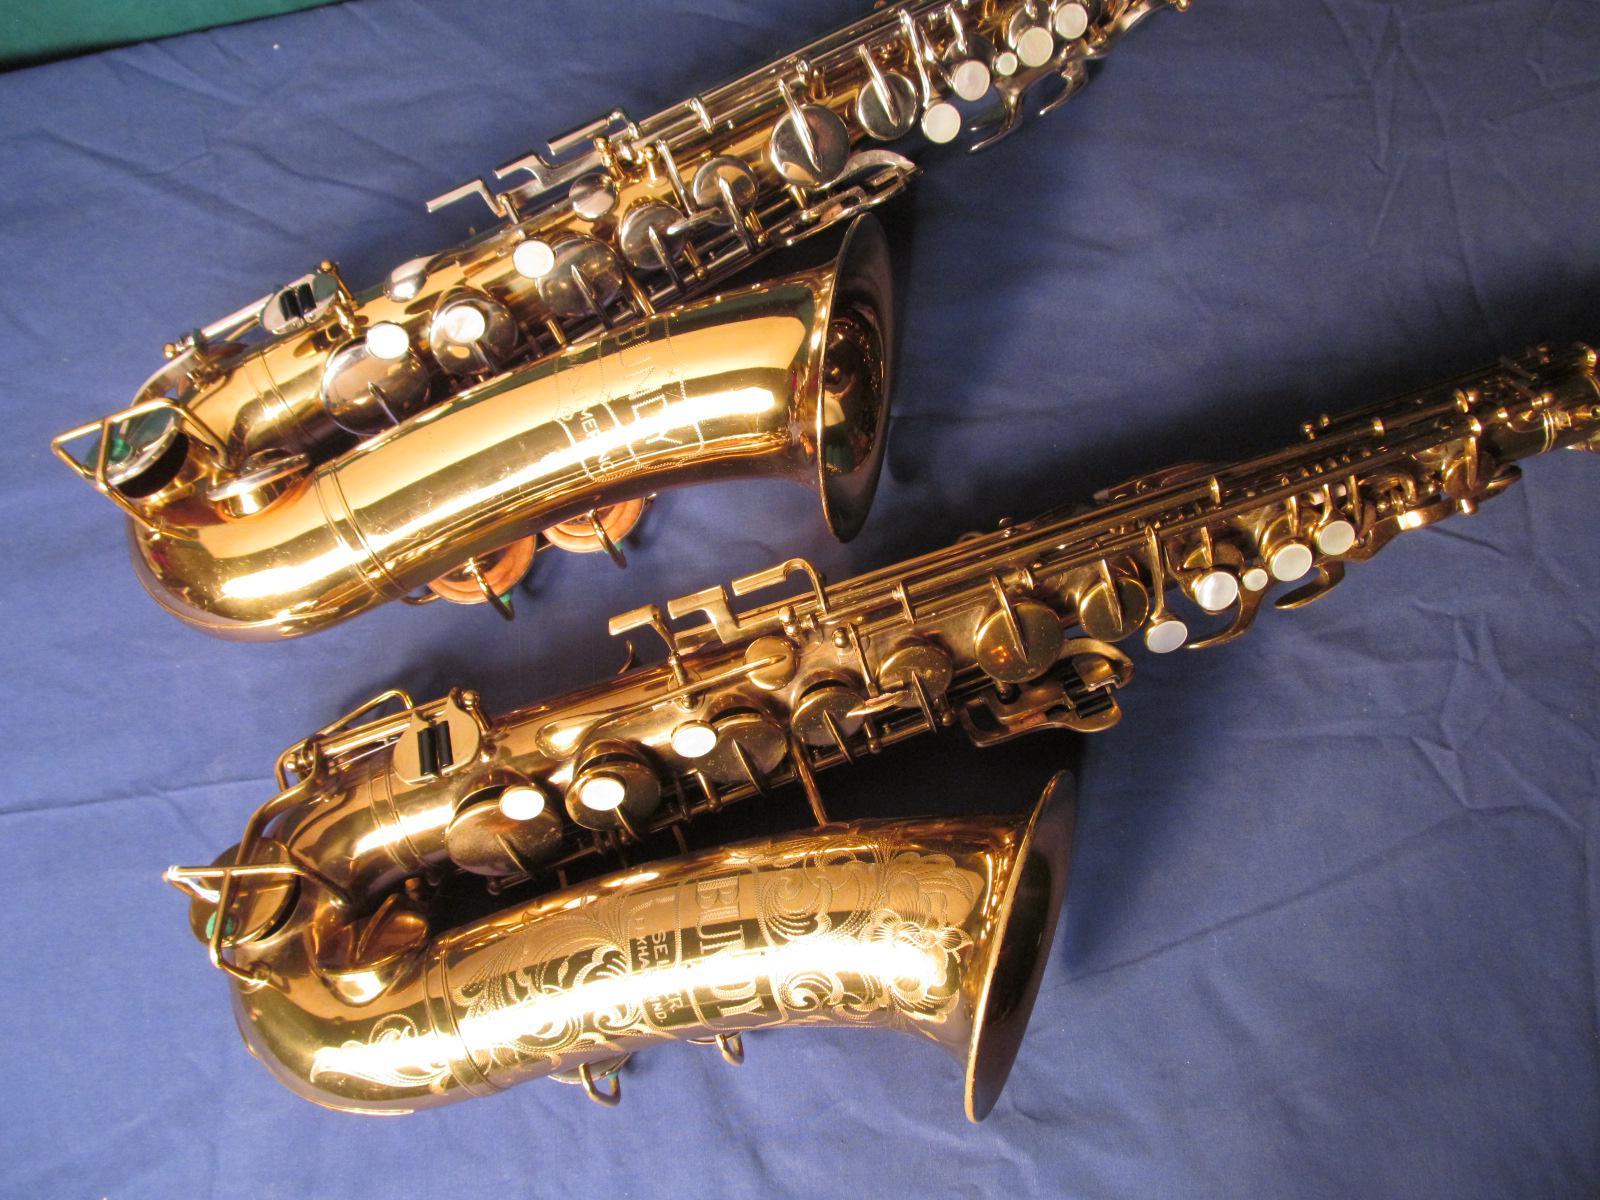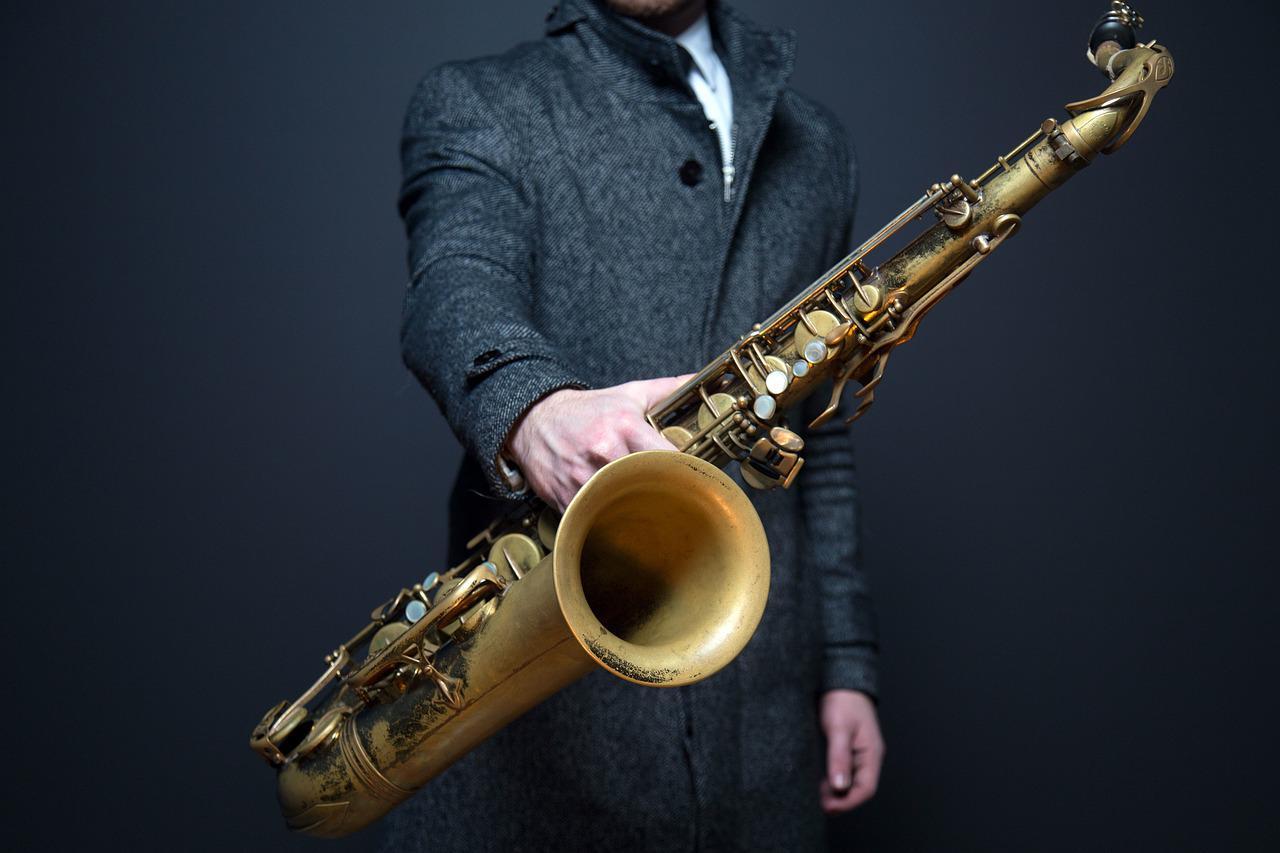The first image is the image on the left, the second image is the image on the right. Examine the images to the left and right. Is the description "There is a single sax in one of the images, and two in the other." accurate? Answer yes or no. Yes. The first image is the image on the left, the second image is the image on the right. Considering the images on both sides, is "Each saxophone is displayed with its bell facing rightward and its mouthpiece attached, but no saxophone is held by a person." valid? Answer yes or no. No. 